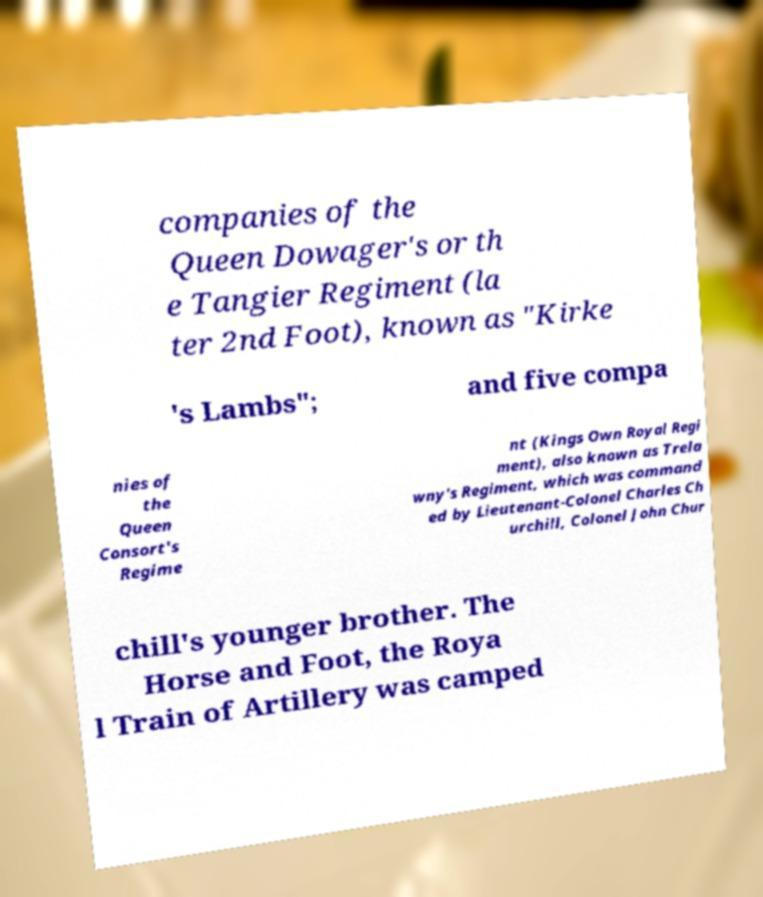Please read and relay the text visible in this image. What does it say? companies of the Queen Dowager's or th e Tangier Regiment (la ter 2nd Foot), known as "Kirke 's Lambs"; and five compa nies of the Queen Consort's Regime nt (Kings Own Royal Regi ment), also known as Trela wny's Regiment, which was command ed by Lieutenant-Colonel Charles Ch urchill, Colonel John Chur chill's younger brother. The Horse and Foot, the Roya l Train of Artillery was camped 